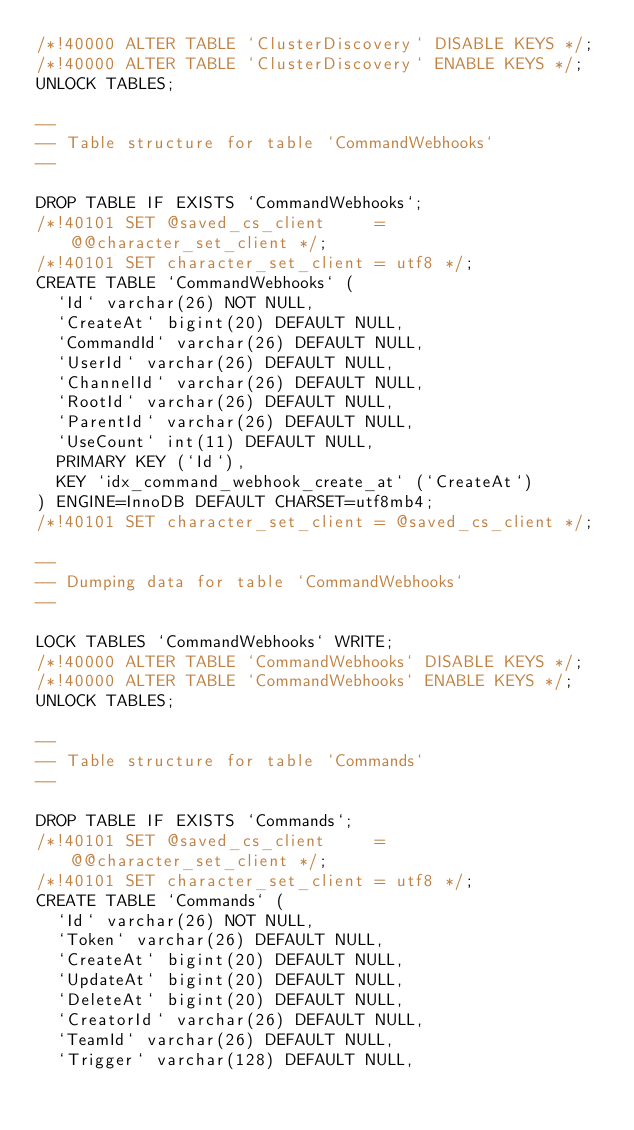Convert code to text. <code><loc_0><loc_0><loc_500><loc_500><_SQL_>/*!40000 ALTER TABLE `ClusterDiscovery` DISABLE KEYS */;
/*!40000 ALTER TABLE `ClusterDiscovery` ENABLE KEYS */;
UNLOCK TABLES;

--
-- Table structure for table `CommandWebhooks`
--

DROP TABLE IF EXISTS `CommandWebhooks`;
/*!40101 SET @saved_cs_client     = @@character_set_client */;
/*!40101 SET character_set_client = utf8 */;
CREATE TABLE `CommandWebhooks` (
  `Id` varchar(26) NOT NULL,
  `CreateAt` bigint(20) DEFAULT NULL,
  `CommandId` varchar(26) DEFAULT NULL,
  `UserId` varchar(26) DEFAULT NULL,
  `ChannelId` varchar(26) DEFAULT NULL,
  `RootId` varchar(26) DEFAULT NULL,
  `ParentId` varchar(26) DEFAULT NULL,
  `UseCount` int(11) DEFAULT NULL,
  PRIMARY KEY (`Id`),
  KEY `idx_command_webhook_create_at` (`CreateAt`)
) ENGINE=InnoDB DEFAULT CHARSET=utf8mb4;
/*!40101 SET character_set_client = @saved_cs_client */;

--
-- Dumping data for table `CommandWebhooks`
--

LOCK TABLES `CommandWebhooks` WRITE;
/*!40000 ALTER TABLE `CommandWebhooks` DISABLE KEYS */;
/*!40000 ALTER TABLE `CommandWebhooks` ENABLE KEYS */;
UNLOCK TABLES;

--
-- Table structure for table `Commands`
--

DROP TABLE IF EXISTS `Commands`;
/*!40101 SET @saved_cs_client     = @@character_set_client */;
/*!40101 SET character_set_client = utf8 */;
CREATE TABLE `Commands` (
  `Id` varchar(26) NOT NULL,
  `Token` varchar(26) DEFAULT NULL,
  `CreateAt` bigint(20) DEFAULT NULL,
  `UpdateAt` bigint(20) DEFAULT NULL,
  `DeleteAt` bigint(20) DEFAULT NULL,
  `CreatorId` varchar(26) DEFAULT NULL,
  `TeamId` varchar(26) DEFAULT NULL,
  `Trigger` varchar(128) DEFAULT NULL,</code> 